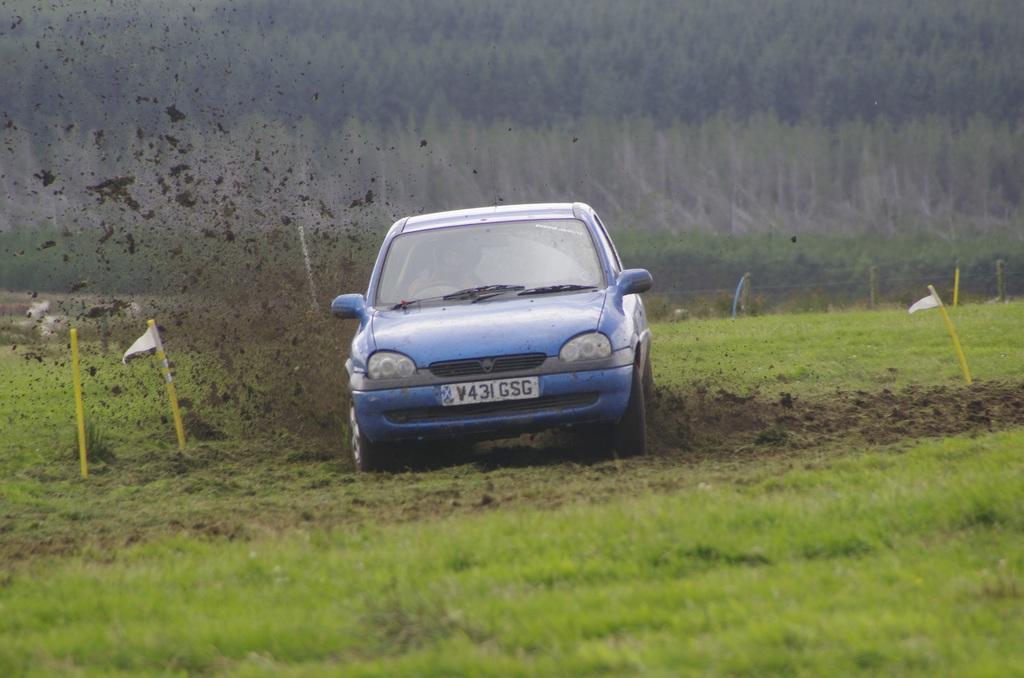In one or two sentences, can you explain what this image depicts? In the image there is a car and a lot of sand is dispersion around the car, the land is covered with grass and in the background there are many trees. 